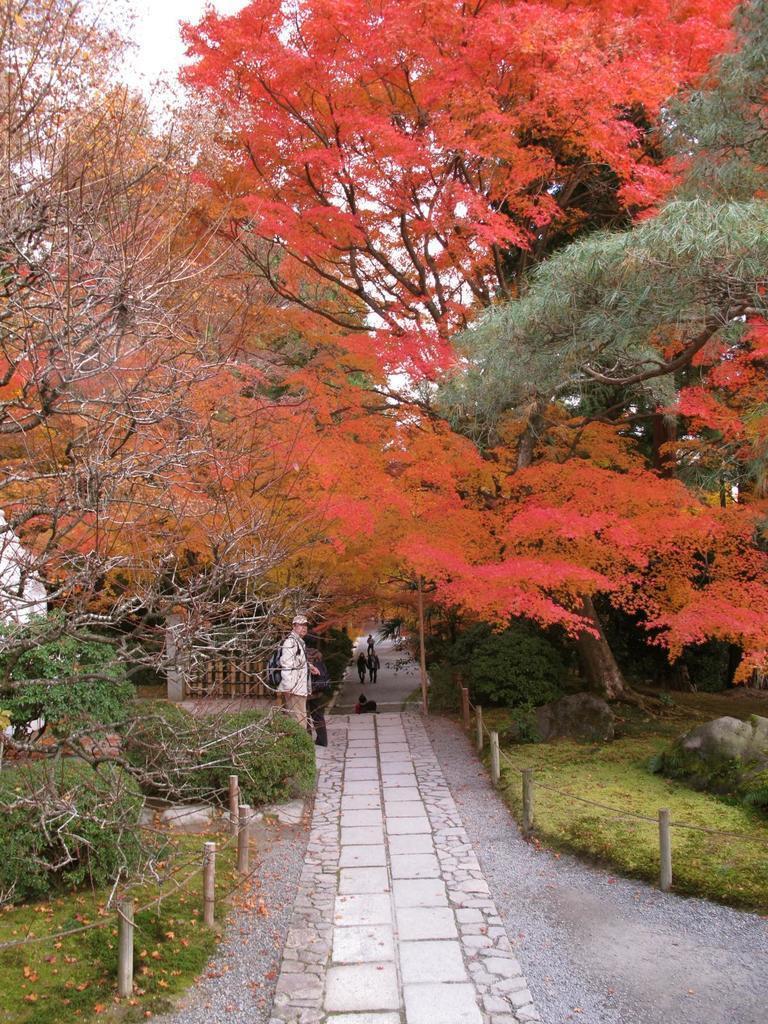In one or two sentences, can you explain what this image depicts? In the foreground of the picture there are plants, rock, grass, path and dry leaves. In the middle of the picture we can see trees, people, walls and plants. At the top there is sky. 